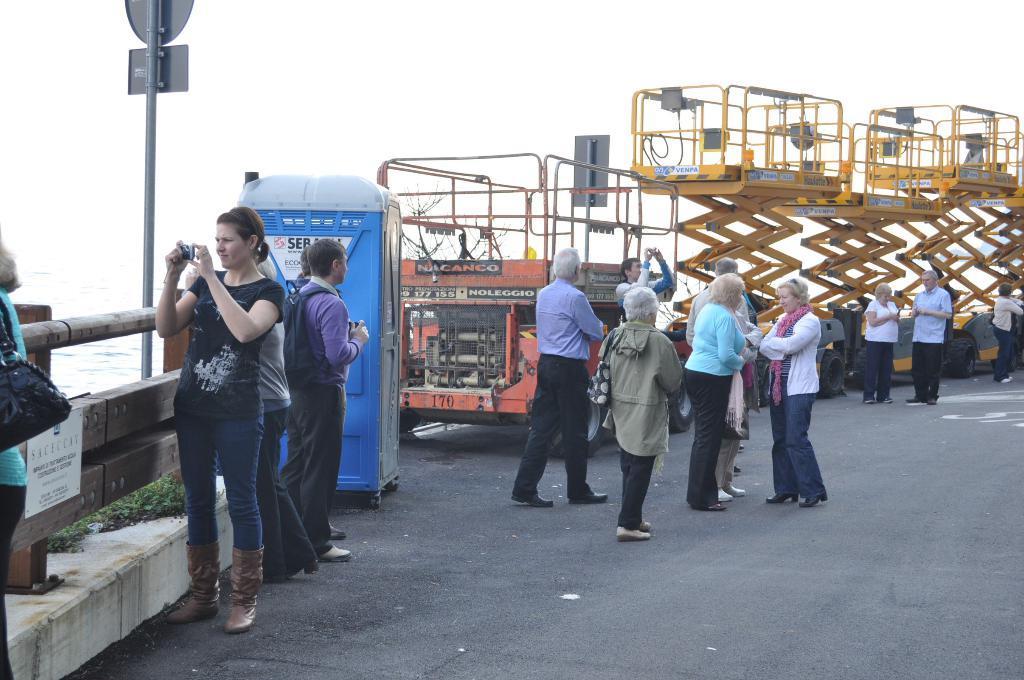In one or two sentences, can you explain what this image depicts? In the image few people are standing and holding cameras in their hands. Behind them there is a vehicle and pole. In the left corner of the image there is a fencing. Behind the fencing there is water. At the top of the image there is sky. 